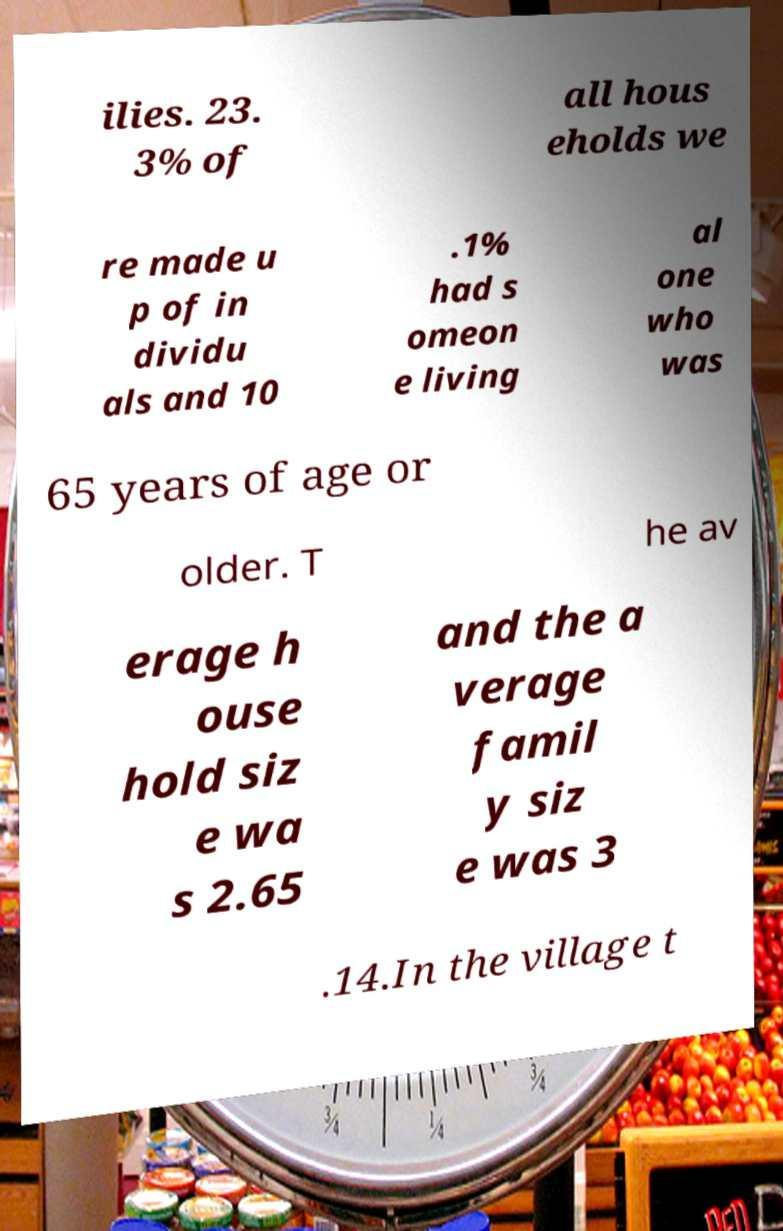What messages or text are displayed in this image? I need them in a readable, typed format. ilies. 23. 3% of all hous eholds we re made u p of in dividu als and 10 .1% had s omeon e living al one who was 65 years of age or older. T he av erage h ouse hold siz e wa s 2.65 and the a verage famil y siz e was 3 .14.In the village t 